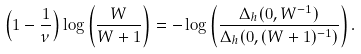<formula> <loc_0><loc_0><loc_500><loc_500>\left ( 1 - \frac { 1 } { \nu } \right ) \log \left ( \frac { W } { W + 1 } \right ) = - \log \left ( \frac { \Delta _ { h } ( 0 , W ^ { - 1 } ) } { \Delta _ { h } ( 0 , ( W + 1 ) ^ { - 1 } ) } \right ) .</formula> 